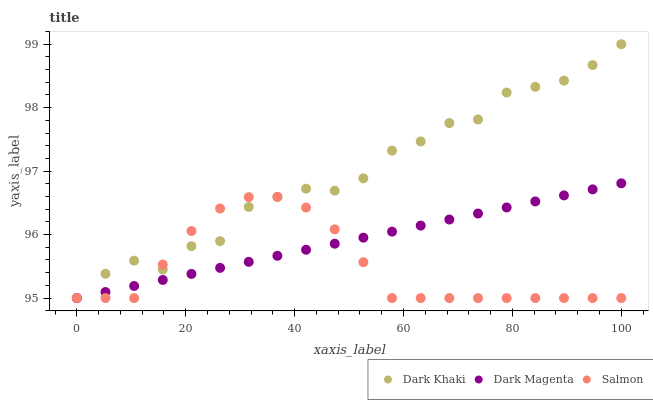Does Salmon have the minimum area under the curve?
Answer yes or no. Yes. Does Dark Khaki have the maximum area under the curve?
Answer yes or no. Yes. Does Dark Magenta have the minimum area under the curve?
Answer yes or no. No. Does Dark Magenta have the maximum area under the curve?
Answer yes or no. No. Is Dark Magenta the smoothest?
Answer yes or no. Yes. Is Dark Khaki the roughest?
Answer yes or no. Yes. Is Salmon the smoothest?
Answer yes or no. No. Is Salmon the roughest?
Answer yes or no. No. Does Dark Khaki have the lowest value?
Answer yes or no. Yes. Does Dark Khaki have the highest value?
Answer yes or no. Yes. Does Dark Magenta have the highest value?
Answer yes or no. No. Does Dark Khaki intersect Dark Magenta?
Answer yes or no. Yes. Is Dark Khaki less than Dark Magenta?
Answer yes or no. No. Is Dark Khaki greater than Dark Magenta?
Answer yes or no. No. 